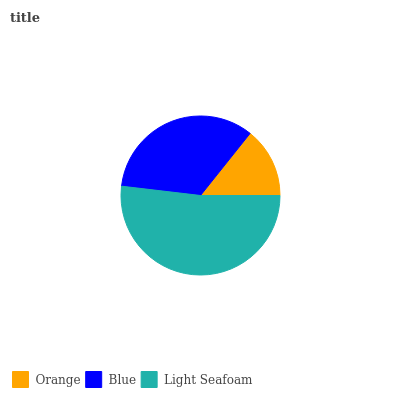Is Orange the minimum?
Answer yes or no. Yes. Is Light Seafoam the maximum?
Answer yes or no. Yes. Is Blue the minimum?
Answer yes or no. No. Is Blue the maximum?
Answer yes or no. No. Is Blue greater than Orange?
Answer yes or no. Yes. Is Orange less than Blue?
Answer yes or no. Yes. Is Orange greater than Blue?
Answer yes or no. No. Is Blue less than Orange?
Answer yes or no. No. Is Blue the high median?
Answer yes or no. Yes. Is Blue the low median?
Answer yes or no. Yes. Is Light Seafoam the high median?
Answer yes or no. No. Is Orange the low median?
Answer yes or no. No. 